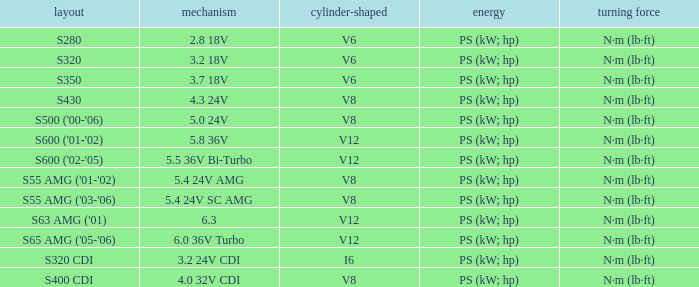Which Torque has a Model of s63 amg ('01)? N·m (lb·ft). 